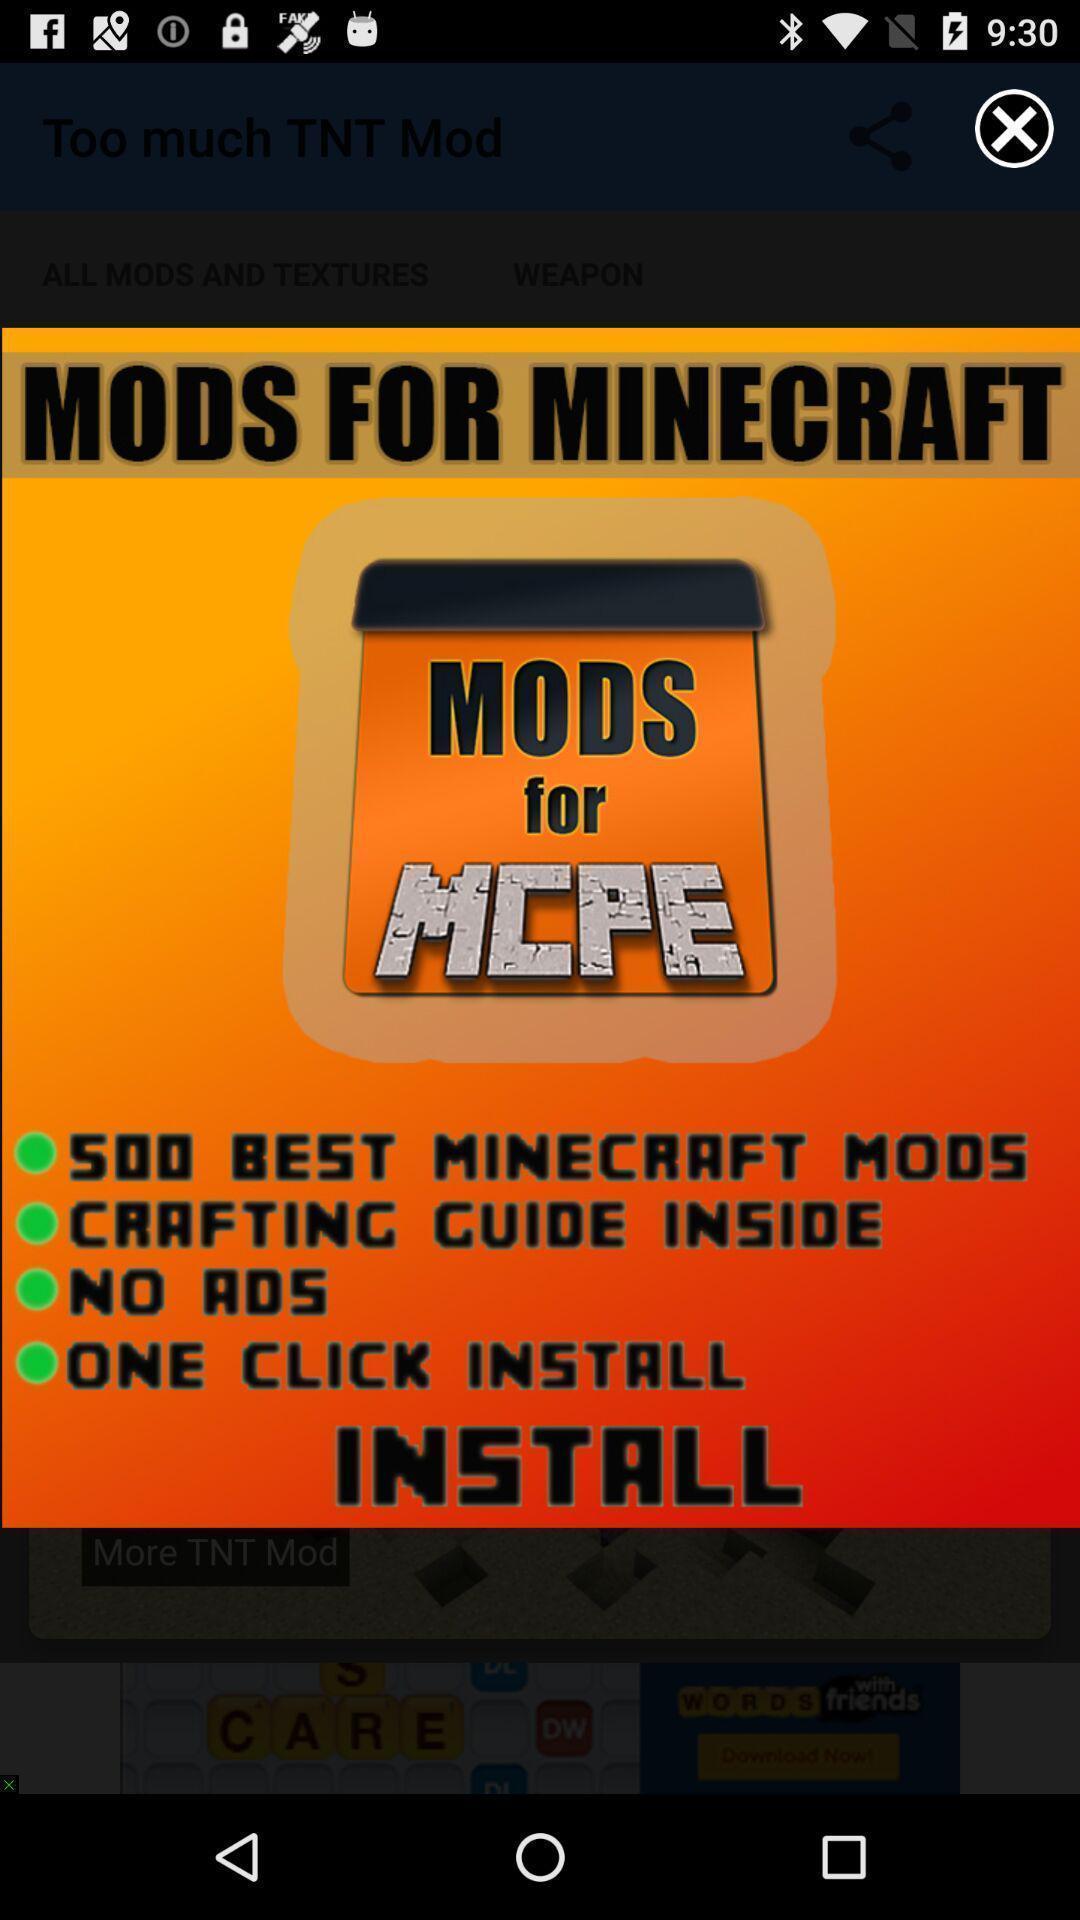What is the overall content of this screenshot? Pop-up showing the suggestion. 